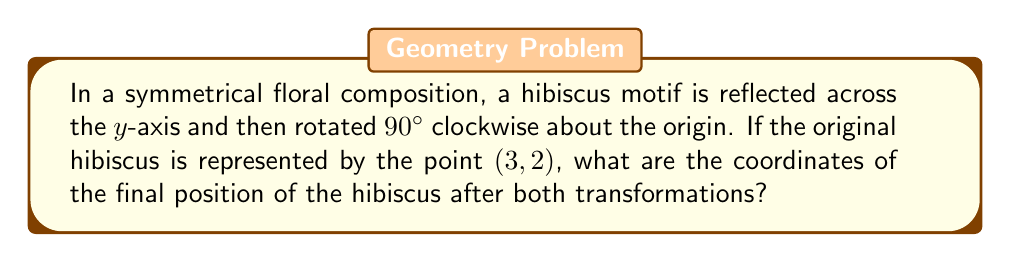Solve this math problem. Let's approach this step-by-step:

1) First, we need to reflect the point (3, 2) across the y-axis:
   - Reflection across the y-axis changes the sign of the x-coordinate
   - The point (3, 2) becomes (-3, 2)

2) Next, we rotate this reflected point 90° clockwise about the origin:
   - A 90° clockwise rotation can be achieved by using the formula:
     $$(x, y) \rightarrow (y, -x)$$

3) Applying this rotation to our point (-3, 2):
   - x becomes y: 2
   - y becomes -x: -(-3) = 3

4) Therefore, after both transformations, the final coordinates are (2, 3)

This process can be summarized mathematically as:

$$(3, 2) \xrightarrow{\text{reflect}} (-3, 2) \xrightarrow{\text{rotate}} (2, 3)$$

[asy]
import geometry;

size(200);
defaultpen(fontsize(10pt));

draw((-4,-4)--(4,-4)--(4,4)--(-4,4)--cycle);
draw((-4,0)--(4,0),arrow=Arrow(TeXHead));
draw((0,-4)--(0,4),arrow=Arrow(TeXHead));

dot((3,2),red);
label("(3,2)",(3,2),NE,red);

dot((-3,2),blue);
label("(-3,2)",(-3,2),NW,blue);

dot((2,3),green);
label("(2,3)",(2,3),NE,green);

draw((3,2)--(-3,2)--(2,3),arrow=Arrow(TeXHead),p=gray+1);
[/asy]
Answer: (2, 3) 